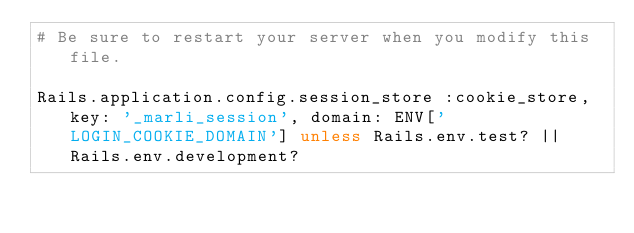Convert code to text. <code><loc_0><loc_0><loc_500><loc_500><_Ruby_># Be sure to restart your server when you modify this file.

Rails.application.config.session_store :cookie_store, key: '_marli_session', domain: ENV['LOGIN_COOKIE_DOMAIN'] unless Rails.env.test? || Rails.env.development?
</code> 